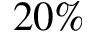<formula> <loc_0><loc_0><loc_500><loc_500>2 0 \%</formula> 